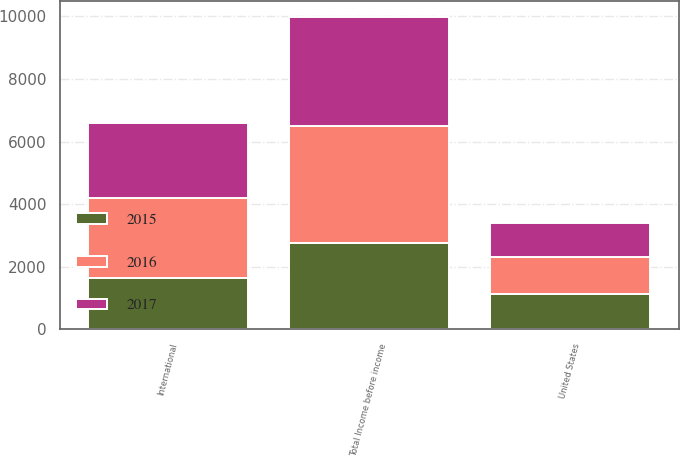Convert chart to OTSL. <chart><loc_0><loc_0><loc_500><loc_500><stacked_bar_chart><ecel><fcel>United States<fcel>International<fcel>Total Income before income<nl><fcel>2017<fcel>1072<fcel>2415<fcel>3487<nl><fcel>2016<fcel>1191<fcel>2547<fcel>3738<nl><fcel>2015<fcel>1118<fcel>1645<fcel>2763<nl></chart> 